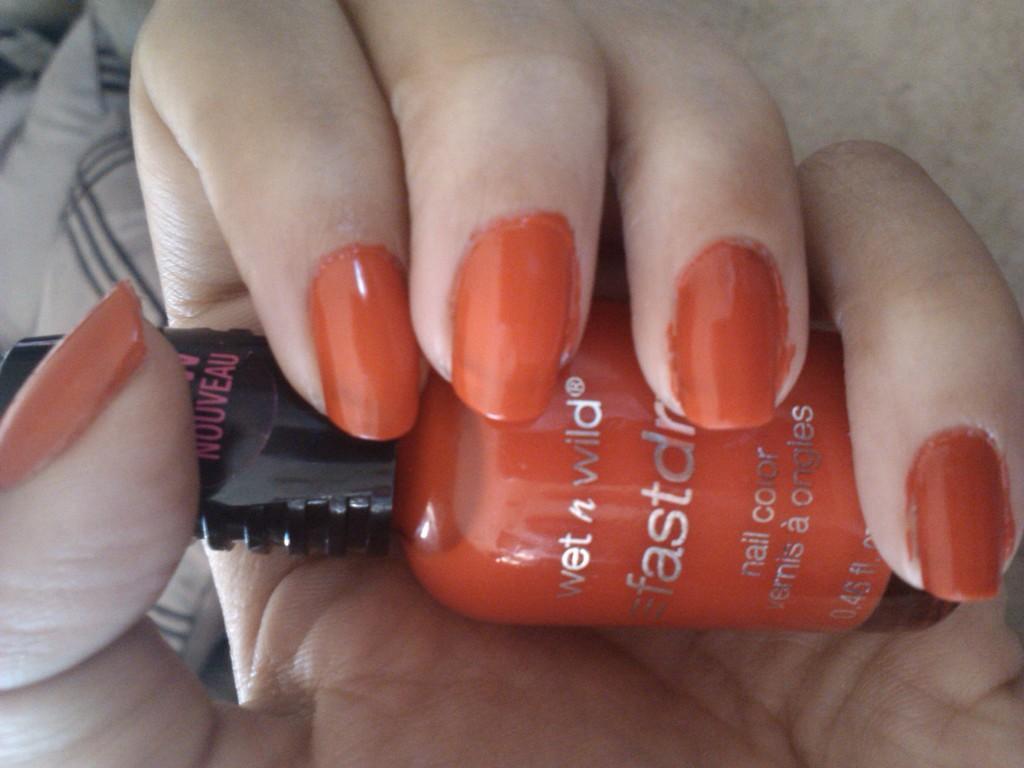Can you describe this image briefly? There is a hand with some nails, holding a nail polish. The nail polish is red in color. And in the background we can observe some pillows. 